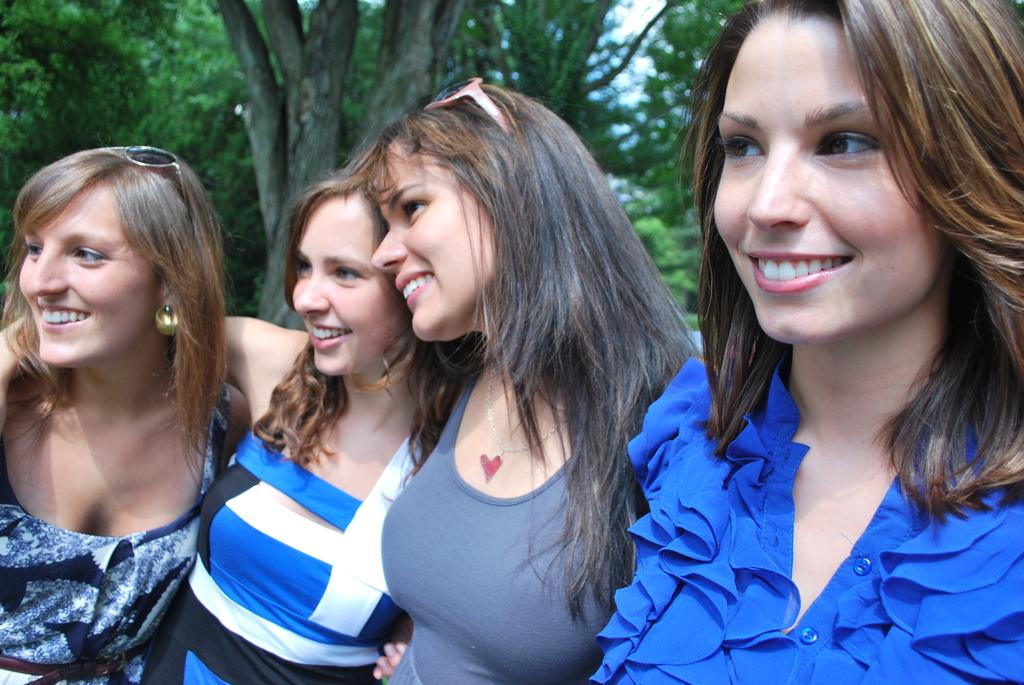How many people are in the image? There are four persons in the image. What are the persons doing in the image? The persons are standing. What is the facial expression of the persons? The persons are smiling. What can be seen in the background of the image? There are trees visible in the background of the image. How are the persons dressed? The persons are wearing different dresses. What type of hobbies do the police officers have in the image? There are no police officers present in the image, so it is not possible to determine their hobbies. 